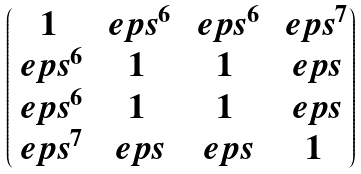<formula> <loc_0><loc_0><loc_500><loc_500>\begin{pmatrix} 1 & \ e p s ^ { 6 } & \ e p s ^ { 6 } & \ e p s ^ { 7 } \\ \ e p s ^ { 6 } & 1 & 1 & \ e p s \\ \ e p s ^ { 6 } & 1 & 1 & \ e p s \\ \ e p s ^ { 7 } & \ e p s & \ e p s & 1 \end{pmatrix}</formula> 